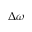Convert formula to latex. <formula><loc_0><loc_0><loc_500><loc_500>\Delta \omega</formula> 